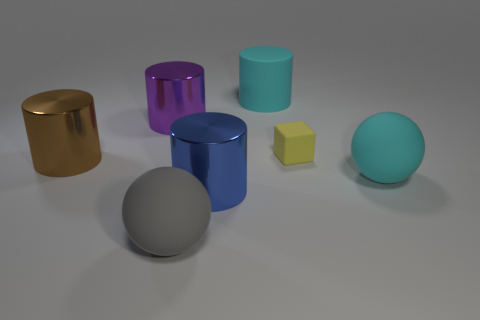What size is the matte sphere that is the same color as the large rubber cylinder?
Make the answer very short. Large. What material is the ball that is the same color as the large rubber cylinder?
Keep it short and to the point. Rubber. What number of big gray spheres have the same material as the yellow block?
Your answer should be compact. 1. What is the size of the blue thing that is the same shape as the brown metallic object?
Give a very brief answer. Large. Is the yellow thing the same size as the gray matte object?
Provide a succinct answer. No. The cyan object that is in front of the big brown shiny object in front of the big shiny cylinder behind the yellow cube is what shape?
Keep it short and to the point. Sphere. What is the color of the large matte thing that is the same shape as the brown shiny thing?
Your answer should be compact. Cyan. There is a rubber thing that is both to the left of the yellow cube and behind the gray thing; how big is it?
Your answer should be compact. Large. There is a large cylinder in front of the large shiny thing that is to the left of the purple object; how many yellow things are in front of it?
Give a very brief answer. 0. What number of big objects are brown metal cylinders or yellow rubber objects?
Your answer should be compact. 1. 